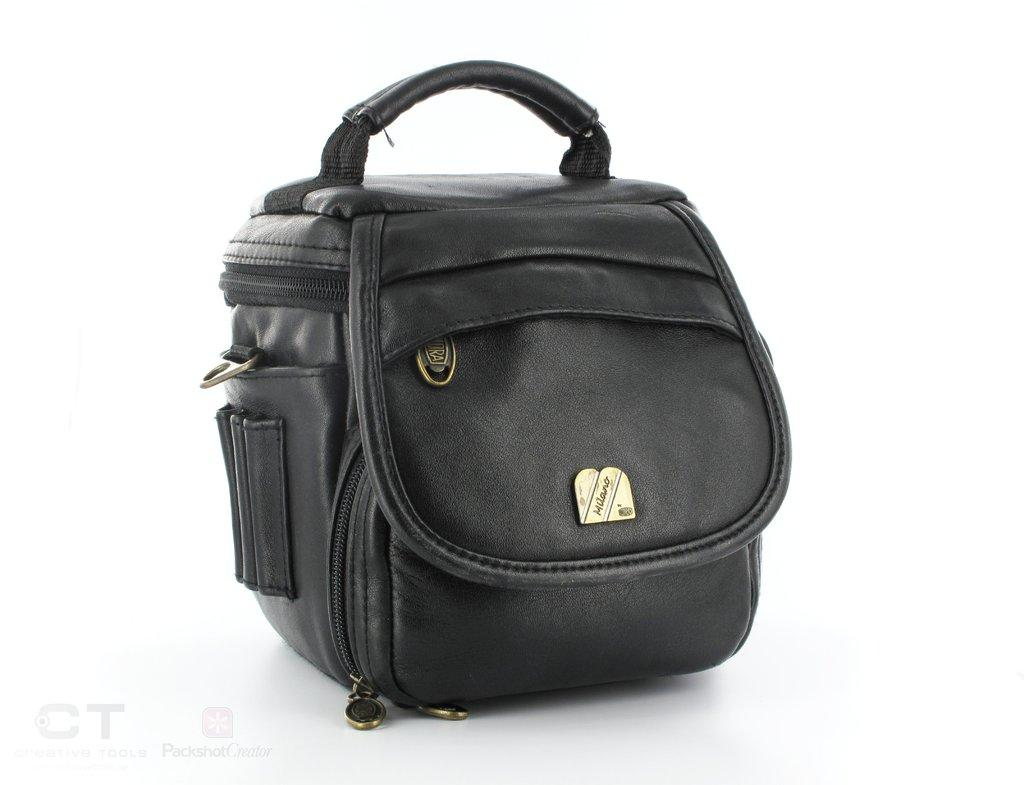What color is the bag that is visible in the image? The bag in the image is black colored. What type of decision can be seen being made by the orange in the image? There is no orange present in the image, and therefore no decision-making can be observed. 